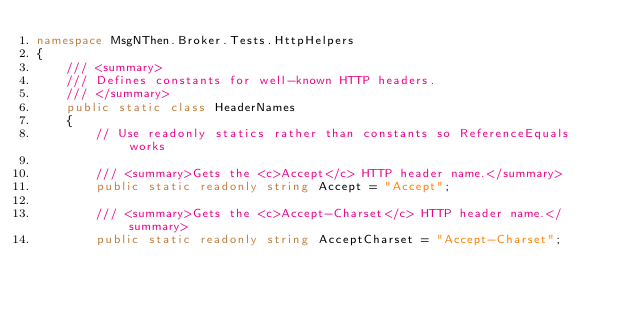Convert code to text. <code><loc_0><loc_0><loc_500><loc_500><_C#_>namespace MsgNThen.Broker.Tests.HttpHelpers
{
    /// <summary>
    /// Defines constants for well-known HTTP headers.
    /// </summary>
    public static class HeaderNames
    {
        // Use readonly statics rather than constants so ReferenceEquals works

        /// <summary>Gets the <c>Accept</c> HTTP header name.</summary>
        public static readonly string Accept = "Accept";

        /// <summary>Gets the <c>Accept-Charset</c> HTTP header name.</summary>
        public static readonly string AcceptCharset = "Accept-Charset";
</code> 